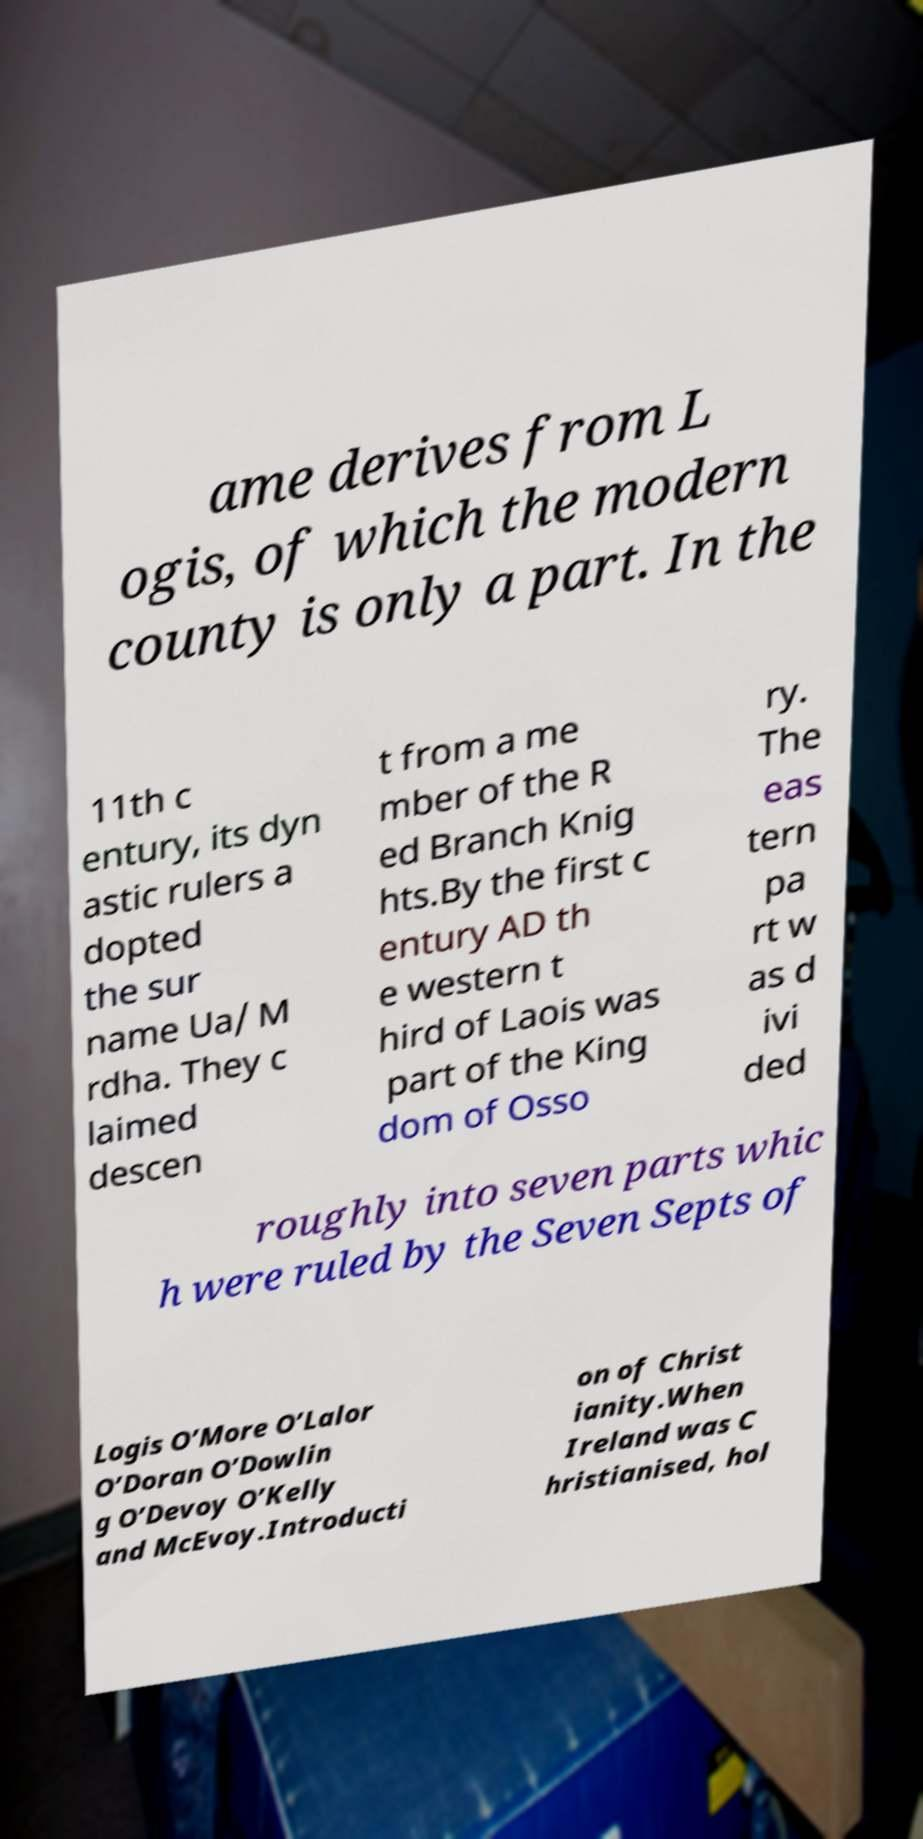Could you assist in decoding the text presented in this image and type it out clearly? ame derives from L ogis, of which the modern county is only a part. In the 11th c entury, its dyn astic rulers a dopted the sur name Ua/ M rdha. They c laimed descen t from a me mber of the R ed Branch Knig hts.By the first c entury AD th e western t hird of Laois was part of the King dom of Osso ry. The eas tern pa rt w as d ivi ded roughly into seven parts whic h were ruled by the Seven Septs of Logis O’More O’Lalor O’Doran O’Dowlin g O’Devoy O’Kelly and McEvoy.Introducti on of Christ ianity.When Ireland was C hristianised, hol 